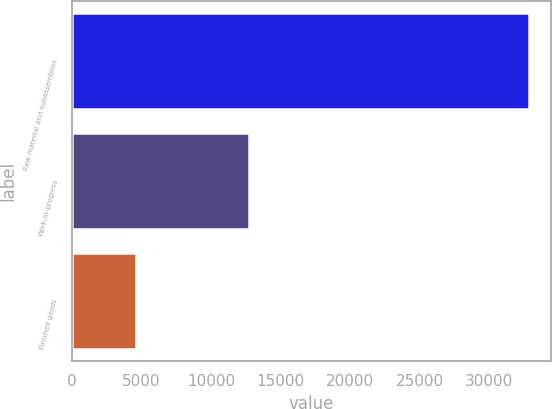Convert chart. <chart><loc_0><loc_0><loc_500><loc_500><bar_chart><fcel>Raw material and subassemblies<fcel>Work-in-progress<fcel>Finished goods<nl><fcel>32825<fcel>12700<fcel>4616<nl></chart> 